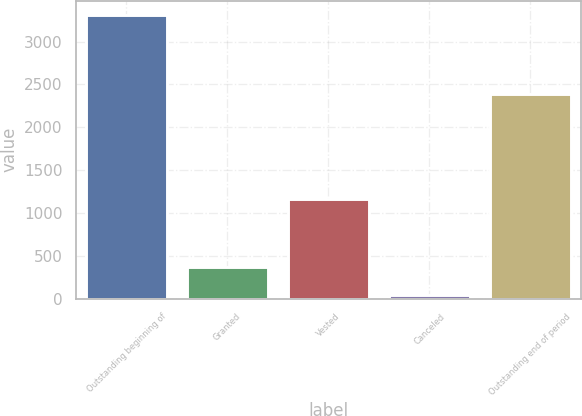Convert chart. <chart><loc_0><loc_0><loc_500><loc_500><bar_chart><fcel>Outstanding beginning of<fcel>Granted<fcel>Vested<fcel>Canceled<fcel>Outstanding end of period<nl><fcel>3313<fcel>374.5<fcel>1159<fcel>48<fcel>2391<nl></chart> 